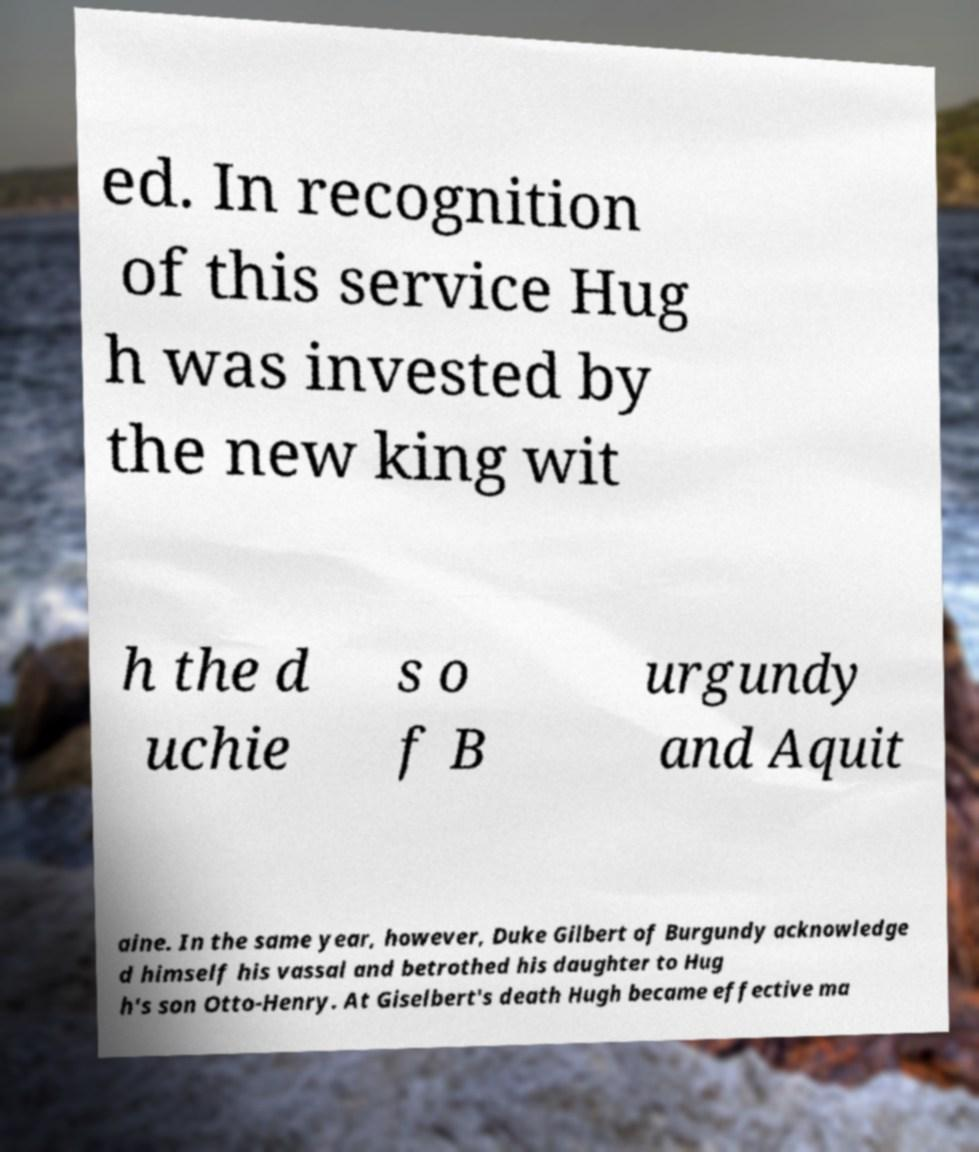Please identify and transcribe the text found in this image. ed. In recognition of this service Hug h was invested by the new king wit h the d uchie s o f B urgundy and Aquit aine. In the same year, however, Duke Gilbert of Burgundy acknowledge d himself his vassal and betrothed his daughter to Hug h's son Otto-Henry. At Giselbert's death Hugh became effective ma 